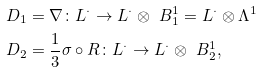Convert formula to latex. <formula><loc_0><loc_0><loc_500><loc_500>D _ { 1 } & = \nabla \colon L ^ { \cdot } \to L ^ { \cdot } \otimes \ B ^ { 1 } _ { 1 } = L ^ { \cdot } \otimes \Lambda ^ { 1 } \\ D _ { 2 } & = \frac { 1 } { 3 } \sigma \circ R \colon L ^ { \cdot } \to L ^ { \cdot } \otimes \ B ^ { 1 } _ { 2 } ,</formula> 